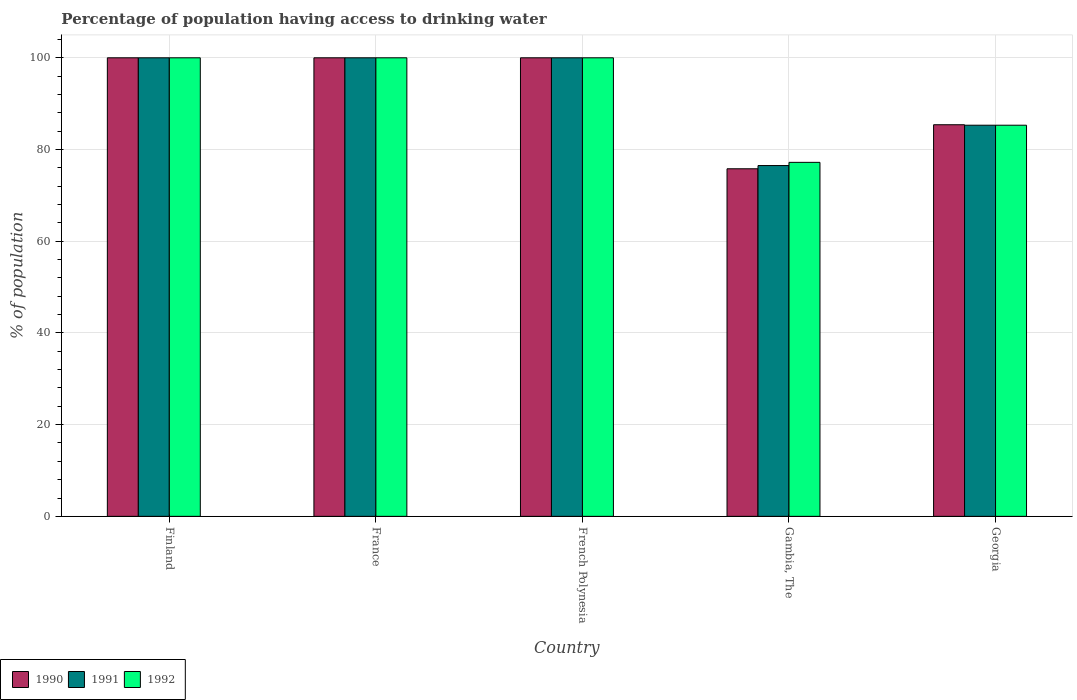How many different coloured bars are there?
Offer a very short reply. 3. Are the number of bars per tick equal to the number of legend labels?
Your answer should be very brief. Yes. Are the number of bars on each tick of the X-axis equal?
Your answer should be compact. Yes. How many bars are there on the 3rd tick from the right?
Make the answer very short. 3. What is the label of the 2nd group of bars from the left?
Keep it short and to the point. France. In how many cases, is the number of bars for a given country not equal to the number of legend labels?
Make the answer very short. 0. What is the percentage of population having access to drinking water in 1992 in Georgia?
Offer a terse response. 85.3. Across all countries, what is the minimum percentage of population having access to drinking water in 1991?
Give a very brief answer. 76.5. In which country was the percentage of population having access to drinking water in 1990 minimum?
Your answer should be very brief. Gambia, The. What is the total percentage of population having access to drinking water in 1990 in the graph?
Ensure brevity in your answer.  461.2. What is the difference between the percentage of population having access to drinking water in 1992 in Finland and that in French Polynesia?
Your response must be concise. 0. What is the average percentage of population having access to drinking water in 1992 per country?
Offer a terse response. 92.5. In how many countries, is the percentage of population having access to drinking water in 1992 greater than 20 %?
Your response must be concise. 5. What is the ratio of the percentage of population having access to drinking water in 1991 in French Polynesia to that in Gambia, The?
Offer a very short reply. 1.31. Is the percentage of population having access to drinking water in 1992 in France less than that in French Polynesia?
Provide a short and direct response. No. What is the difference between the highest and the lowest percentage of population having access to drinking water in 1992?
Provide a short and direct response. 22.8. Is the sum of the percentage of population having access to drinking water in 1992 in France and French Polynesia greater than the maximum percentage of population having access to drinking water in 1990 across all countries?
Your response must be concise. Yes. What does the 1st bar from the left in Georgia represents?
Your answer should be very brief. 1990. How many bars are there?
Ensure brevity in your answer.  15. Are all the bars in the graph horizontal?
Offer a terse response. No. How many countries are there in the graph?
Offer a very short reply. 5. Are the values on the major ticks of Y-axis written in scientific E-notation?
Make the answer very short. No. Does the graph contain any zero values?
Provide a succinct answer. No. How many legend labels are there?
Make the answer very short. 3. What is the title of the graph?
Your answer should be compact. Percentage of population having access to drinking water. Does "2005" appear as one of the legend labels in the graph?
Keep it short and to the point. No. What is the label or title of the X-axis?
Provide a succinct answer. Country. What is the label or title of the Y-axis?
Keep it short and to the point. % of population. What is the % of population of 1991 in Finland?
Provide a short and direct response. 100. What is the % of population in 1990 in French Polynesia?
Your answer should be very brief. 100. What is the % of population in 1991 in French Polynesia?
Ensure brevity in your answer.  100. What is the % of population in 1990 in Gambia, The?
Your answer should be compact. 75.8. What is the % of population of 1991 in Gambia, The?
Provide a succinct answer. 76.5. What is the % of population in 1992 in Gambia, The?
Keep it short and to the point. 77.2. What is the % of population of 1990 in Georgia?
Offer a terse response. 85.4. What is the % of population of 1991 in Georgia?
Provide a succinct answer. 85.3. What is the % of population of 1992 in Georgia?
Provide a short and direct response. 85.3. Across all countries, what is the maximum % of population in 1990?
Provide a short and direct response. 100. Across all countries, what is the maximum % of population in 1991?
Make the answer very short. 100. Across all countries, what is the maximum % of population of 1992?
Keep it short and to the point. 100. Across all countries, what is the minimum % of population in 1990?
Offer a very short reply. 75.8. Across all countries, what is the minimum % of population of 1991?
Your response must be concise. 76.5. Across all countries, what is the minimum % of population in 1992?
Ensure brevity in your answer.  77.2. What is the total % of population in 1990 in the graph?
Keep it short and to the point. 461.2. What is the total % of population in 1991 in the graph?
Provide a short and direct response. 461.8. What is the total % of population in 1992 in the graph?
Your answer should be very brief. 462.5. What is the difference between the % of population in 1990 in Finland and that in French Polynesia?
Offer a terse response. 0. What is the difference between the % of population of 1990 in Finland and that in Gambia, The?
Your answer should be very brief. 24.2. What is the difference between the % of population in 1992 in Finland and that in Gambia, The?
Your answer should be compact. 22.8. What is the difference between the % of population of 1990 in Finland and that in Georgia?
Provide a succinct answer. 14.6. What is the difference between the % of population in 1992 in Finland and that in Georgia?
Give a very brief answer. 14.7. What is the difference between the % of population of 1991 in France and that in French Polynesia?
Provide a succinct answer. 0. What is the difference between the % of population in 1992 in France and that in French Polynesia?
Make the answer very short. 0. What is the difference between the % of population in 1990 in France and that in Gambia, The?
Provide a short and direct response. 24.2. What is the difference between the % of population of 1992 in France and that in Gambia, The?
Keep it short and to the point. 22.8. What is the difference between the % of population in 1990 in France and that in Georgia?
Provide a short and direct response. 14.6. What is the difference between the % of population in 1990 in French Polynesia and that in Gambia, The?
Your response must be concise. 24.2. What is the difference between the % of population in 1992 in French Polynesia and that in Gambia, The?
Offer a very short reply. 22.8. What is the difference between the % of population in 1990 in French Polynesia and that in Georgia?
Keep it short and to the point. 14.6. What is the difference between the % of population in 1990 in Finland and the % of population in 1991 in France?
Your answer should be very brief. 0. What is the difference between the % of population of 1990 in Finland and the % of population of 1992 in France?
Provide a succinct answer. 0. What is the difference between the % of population of 1991 in Finland and the % of population of 1992 in France?
Give a very brief answer. 0. What is the difference between the % of population in 1990 in Finland and the % of population in 1992 in French Polynesia?
Your response must be concise. 0. What is the difference between the % of population in 1990 in Finland and the % of population in 1992 in Gambia, The?
Keep it short and to the point. 22.8. What is the difference between the % of population of 1991 in Finland and the % of population of 1992 in Gambia, The?
Keep it short and to the point. 22.8. What is the difference between the % of population of 1990 in Finland and the % of population of 1991 in Georgia?
Your answer should be compact. 14.7. What is the difference between the % of population of 1990 in Finland and the % of population of 1992 in Georgia?
Keep it short and to the point. 14.7. What is the difference between the % of population of 1991 in Finland and the % of population of 1992 in Georgia?
Offer a very short reply. 14.7. What is the difference between the % of population of 1990 in France and the % of population of 1991 in Gambia, The?
Provide a short and direct response. 23.5. What is the difference between the % of population of 1990 in France and the % of population of 1992 in Gambia, The?
Your answer should be compact. 22.8. What is the difference between the % of population of 1991 in France and the % of population of 1992 in Gambia, The?
Your response must be concise. 22.8. What is the difference between the % of population in 1990 in France and the % of population in 1991 in Georgia?
Ensure brevity in your answer.  14.7. What is the difference between the % of population of 1991 in France and the % of population of 1992 in Georgia?
Make the answer very short. 14.7. What is the difference between the % of population in 1990 in French Polynesia and the % of population in 1991 in Gambia, The?
Offer a terse response. 23.5. What is the difference between the % of population of 1990 in French Polynesia and the % of population of 1992 in Gambia, The?
Give a very brief answer. 22.8. What is the difference between the % of population in 1991 in French Polynesia and the % of population in 1992 in Gambia, The?
Make the answer very short. 22.8. What is the difference between the % of population in 1990 in French Polynesia and the % of population in 1991 in Georgia?
Your answer should be compact. 14.7. What is the difference between the % of population of 1990 in French Polynesia and the % of population of 1992 in Georgia?
Your answer should be compact. 14.7. What is the difference between the % of population in 1990 in Gambia, The and the % of population in 1992 in Georgia?
Your answer should be compact. -9.5. What is the average % of population of 1990 per country?
Offer a very short reply. 92.24. What is the average % of population of 1991 per country?
Your answer should be very brief. 92.36. What is the average % of population of 1992 per country?
Make the answer very short. 92.5. What is the difference between the % of population in 1990 and % of population in 1991 in Finland?
Make the answer very short. 0. What is the difference between the % of population of 1990 and % of population of 1992 in Finland?
Keep it short and to the point. 0. What is the difference between the % of population of 1991 and % of population of 1992 in Finland?
Give a very brief answer. 0. What is the difference between the % of population of 1990 and % of population of 1992 in France?
Ensure brevity in your answer.  0. What is the difference between the % of population of 1991 and % of population of 1992 in French Polynesia?
Offer a very short reply. 0. What is the difference between the % of population in 1990 and % of population in 1992 in Gambia, The?
Ensure brevity in your answer.  -1.4. What is the difference between the % of population of 1990 and % of population of 1991 in Georgia?
Offer a very short reply. 0.1. What is the difference between the % of population in 1991 and % of population in 1992 in Georgia?
Offer a terse response. 0. What is the ratio of the % of population in 1990 in Finland to that in France?
Give a very brief answer. 1. What is the ratio of the % of population in 1991 in Finland to that in France?
Keep it short and to the point. 1. What is the ratio of the % of population in 1992 in Finland to that in France?
Offer a very short reply. 1. What is the ratio of the % of population in 1991 in Finland to that in French Polynesia?
Your answer should be compact. 1. What is the ratio of the % of population of 1990 in Finland to that in Gambia, The?
Make the answer very short. 1.32. What is the ratio of the % of population of 1991 in Finland to that in Gambia, The?
Provide a short and direct response. 1.31. What is the ratio of the % of population in 1992 in Finland to that in Gambia, The?
Make the answer very short. 1.3. What is the ratio of the % of population in 1990 in Finland to that in Georgia?
Keep it short and to the point. 1.17. What is the ratio of the % of population of 1991 in Finland to that in Georgia?
Your answer should be very brief. 1.17. What is the ratio of the % of population in 1992 in Finland to that in Georgia?
Give a very brief answer. 1.17. What is the ratio of the % of population of 1991 in France to that in French Polynesia?
Your response must be concise. 1. What is the ratio of the % of population of 1990 in France to that in Gambia, The?
Provide a succinct answer. 1.32. What is the ratio of the % of population in 1991 in France to that in Gambia, The?
Offer a very short reply. 1.31. What is the ratio of the % of population of 1992 in France to that in Gambia, The?
Your answer should be very brief. 1.3. What is the ratio of the % of population in 1990 in France to that in Georgia?
Give a very brief answer. 1.17. What is the ratio of the % of population of 1991 in France to that in Georgia?
Ensure brevity in your answer.  1.17. What is the ratio of the % of population in 1992 in France to that in Georgia?
Give a very brief answer. 1.17. What is the ratio of the % of population of 1990 in French Polynesia to that in Gambia, The?
Offer a terse response. 1.32. What is the ratio of the % of population of 1991 in French Polynesia to that in Gambia, The?
Offer a terse response. 1.31. What is the ratio of the % of population of 1992 in French Polynesia to that in Gambia, The?
Your answer should be very brief. 1.3. What is the ratio of the % of population in 1990 in French Polynesia to that in Georgia?
Make the answer very short. 1.17. What is the ratio of the % of population of 1991 in French Polynesia to that in Georgia?
Keep it short and to the point. 1.17. What is the ratio of the % of population of 1992 in French Polynesia to that in Georgia?
Give a very brief answer. 1.17. What is the ratio of the % of population of 1990 in Gambia, The to that in Georgia?
Make the answer very short. 0.89. What is the ratio of the % of population in 1991 in Gambia, The to that in Georgia?
Offer a very short reply. 0.9. What is the ratio of the % of population of 1992 in Gambia, The to that in Georgia?
Your answer should be compact. 0.91. What is the difference between the highest and the second highest % of population in 1990?
Ensure brevity in your answer.  0. What is the difference between the highest and the second highest % of population of 1992?
Your response must be concise. 0. What is the difference between the highest and the lowest % of population of 1990?
Your response must be concise. 24.2. What is the difference between the highest and the lowest % of population in 1991?
Offer a very short reply. 23.5. What is the difference between the highest and the lowest % of population of 1992?
Provide a short and direct response. 22.8. 